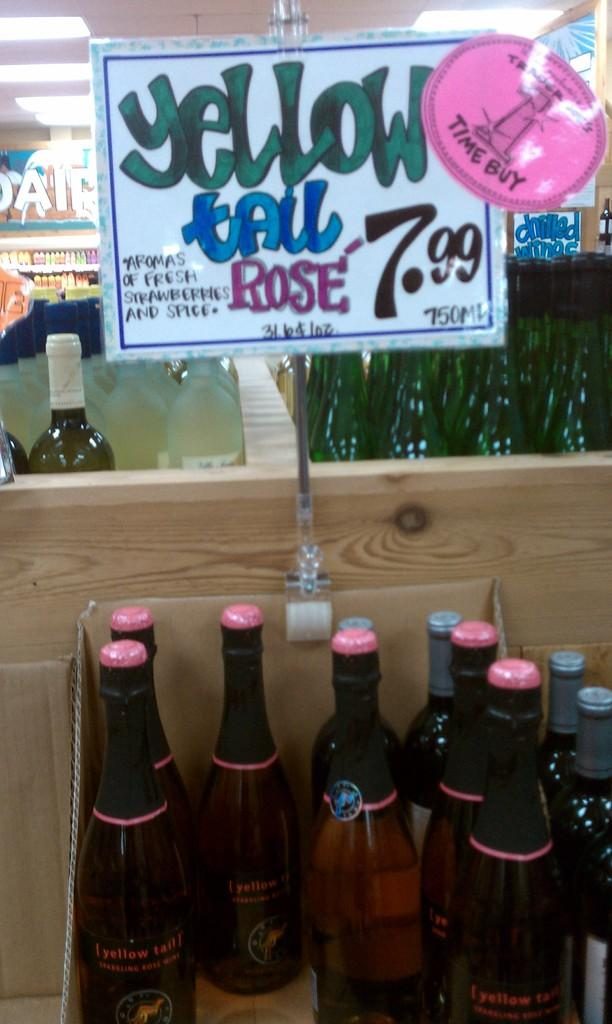<image>
Give a short and clear explanation of the subsequent image. A sign says "yellow tail rose" above some bottles. 